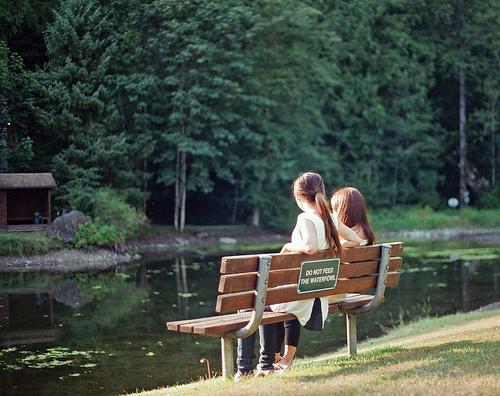How many girls are on the bench?
Give a very brief answer. 2. 